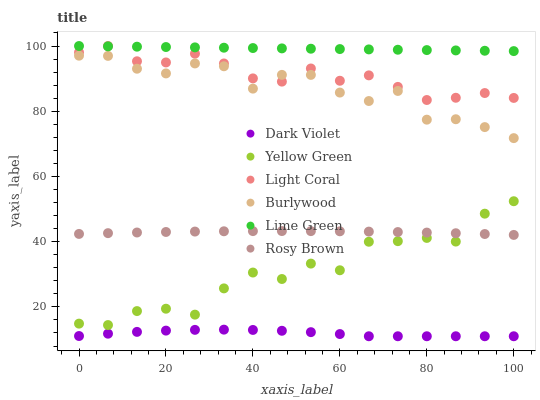Does Dark Violet have the minimum area under the curve?
Answer yes or no. Yes. Does Lime Green have the maximum area under the curve?
Answer yes or no. Yes. Does Burlywood have the minimum area under the curve?
Answer yes or no. No. Does Burlywood have the maximum area under the curve?
Answer yes or no. No. Is Lime Green the smoothest?
Answer yes or no. Yes. Is Yellow Green the roughest?
Answer yes or no. Yes. Is Burlywood the smoothest?
Answer yes or no. No. Is Burlywood the roughest?
Answer yes or no. No. Does Dark Violet have the lowest value?
Answer yes or no. Yes. Does Burlywood have the lowest value?
Answer yes or no. No. Does Lime Green have the highest value?
Answer yes or no. Yes. Does Burlywood have the highest value?
Answer yes or no. No. Is Yellow Green less than Burlywood?
Answer yes or no. Yes. Is Lime Green greater than Rosy Brown?
Answer yes or no. Yes. Does Light Coral intersect Burlywood?
Answer yes or no. Yes. Is Light Coral less than Burlywood?
Answer yes or no. No. Is Light Coral greater than Burlywood?
Answer yes or no. No. Does Yellow Green intersect Burlywood?
Answer yes or no. No. 